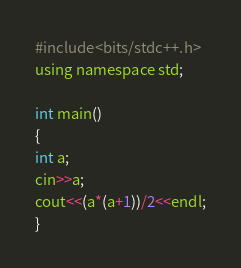<code> <loc_0><loc_0><loc_500><loc_500><_Awk_>#include<bits/stdc++.h>
using namespace std;

int main()
{
int a;
cin>>a;
cout<<(a*(a+1))/2<<endl;
}</code> 